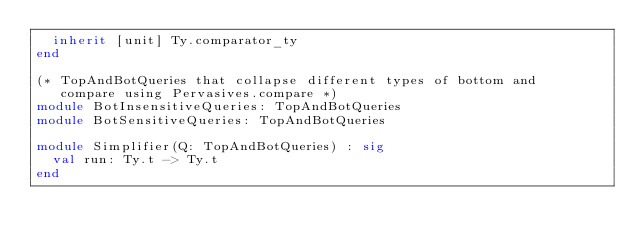Convert code to text. <code><loc_0><loc_0><loc_500><loc_500><_OCaml_>  inherit [unit] Ty.comparator_ty
end

(* TopAndBotQueries that collapse different types of bottom and
   compare using Pervasives.compare *)
module BotInsensitiveQueries: TopAndBotQueries
module BotSensitiveQueries: TopAndBotQueries

module Simplifier(Q: TopAndBotQueries) : sig
  val run: Ty.t -> Ty.t
end
</code> 